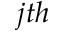Convert formula to latex. <formula><loc_0><loc_0><loc_500><loc_500>j t h</formula> 